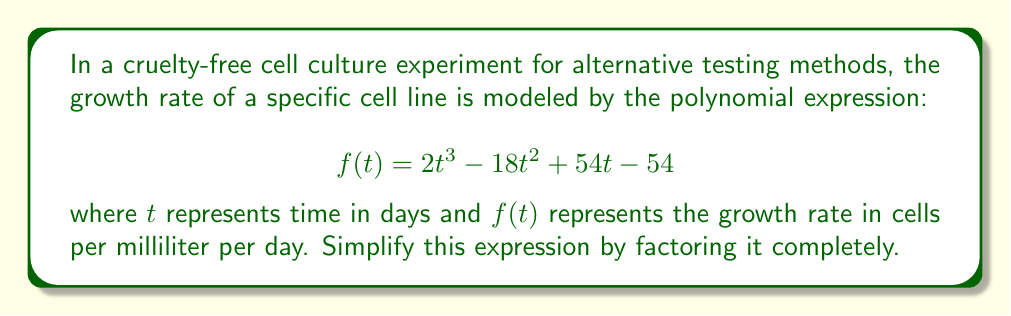Solve this math problem. Let's approach this step-by-step:

1) First, we can factor out the greatest common factor (GCF) of all terms:
   $$f(t) = 2(t^3 - 9t^2 + 27t - 27)$$

2) The expression inside the parentheses is a cubic polynomial. Let's try to factor it further by guessing one of its roots. Since the constant term is -27, potential factors could be ±1, ±3, ±9, or ±27. By inspection or trial and error, we can find that (t - 3) is a factor.

3) Divide the polynomial by (t - 3):
   $$(t^2 - 6t + 9)$$

4) The resulting quadratic expression is a perfect square trinomial:
   $$(t - 3)(t - 3)$$

5) Therefore, the original cubic expression can be factored as:
   $$(t - 3)(t - 3)(t - 3)$$

6) Combining this with the factor we extracted in step 1, we get:
   $$f(t) = 2(t - 3)(t - 3)(t - 3)$$

7) This can be written more concisely as:
   $$f(t) = 2(t - 3)^3$$
Answer: $2(t - 3)^3$ 